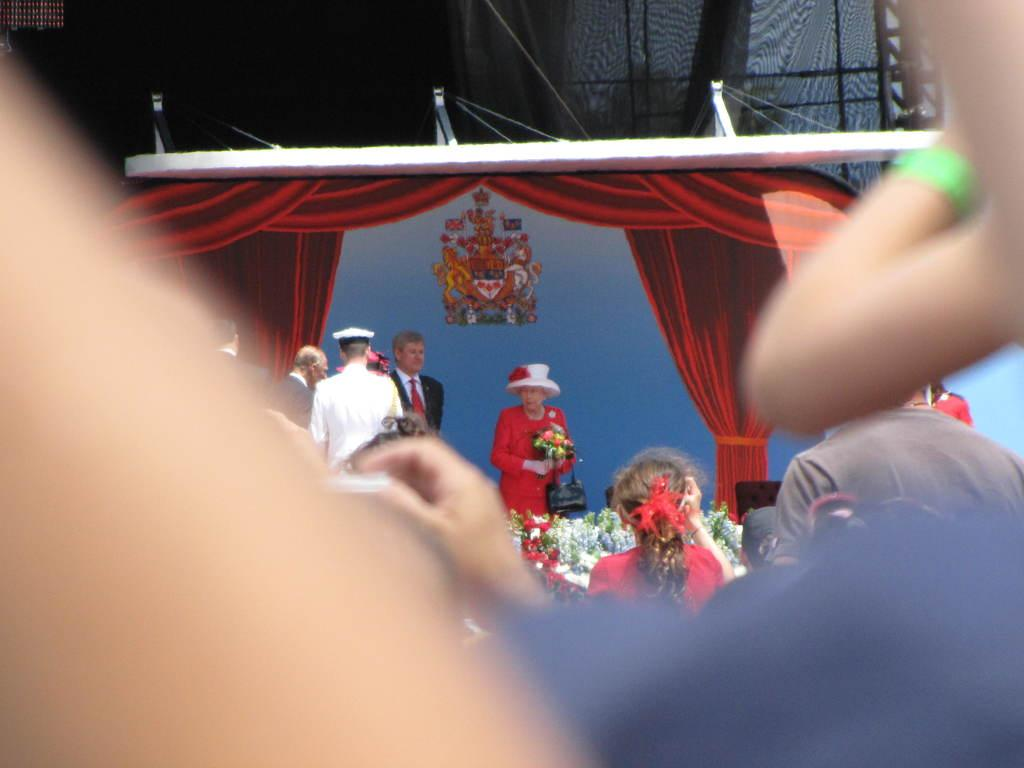What type of window treatment is visible in the image? There are curtains in the image. What else can be seen in the image besides the curtains? There are plants, people, a chair, and a woman holding a bouquet visible in the image. Can you describe the chair in the image? There is a chair in the image, but no specific details about its appearance are provided. What is the woman holding in the image? The woman is holding a bouquet in the image. Is there any additional decoration or marking on any of the objects in the image? Yes, there is a sticker on the backside in the image. What note is the woman singing in the image? There is no indication in the image that the woman is singing, so it cannot be determined from the picture. What type of lead is the woman using to hold the bouquet in the image? The woman is holding the bouquet with her hands, not a lead, as there is no lead present in the image. 